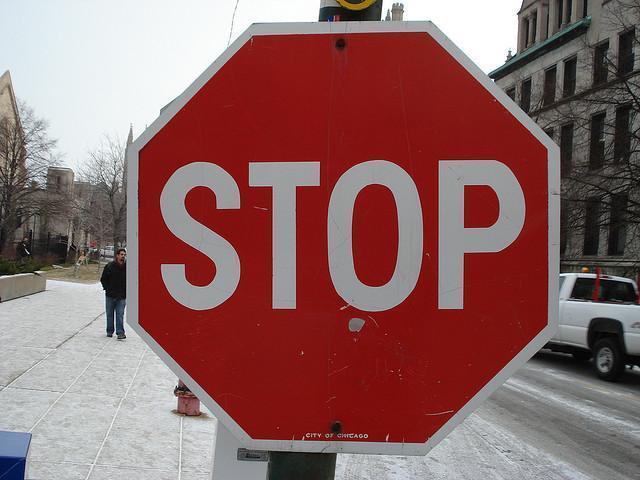How many cows are there?
Give a very brief answer. 0. 